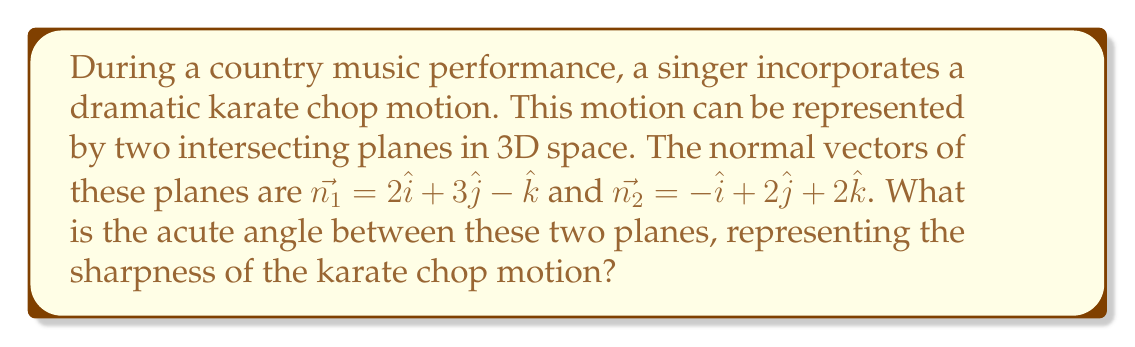Solve this math problem. To find the angle between two intersecting planes, we can use the dot product of their normal vectors. The formula for the angle $\theta$ between two planes with normal vectors $\vec{n_1}$ and $\vec{n_2}$ is:

$$\cos\theta = \frac{|\vec{n_1} \cdot \vec{n_2}|}{|\vec{n_1}||\vec{n_2}|}$$

Step 1: Calculate the dot product $\vec{n_1} \cdot \vec{n_2}$
$$\vec{n_1} \cdot \vec{n_2} = (2)(-1) + (3)(2) + (-1)(2) = -2 + 6 - 2 = 2$$

Step 2: Calculate the magnitudes of $\vec{n_1}$ and $\vec{n_2}$
$$|\vec{n_1}| = \sqrt{2^2 + 3^2 + (-1)^2} = \sqrt{4 + 9 + 1} = \sqrt{14}$$
$$|\vec{n_2}| = \sqrt{(-1)^2 + 2^2 + 2^2} = \sqrt{1 + 4 + 4} = 3$$

Step 3: Apply the formula
$$\cos\theta = \frac{|2|}{\sqrt{14} \cdot 3} = \frac{2}{3\sqrt{14}}$$

Step 4: Take the inverse cosine (arccos) of both sides
$$\theta = \arccos\left(\frac{2}{3\sqrt{14}}\right)$$

Step 5: Calculate the result (in radians)
$$\theta \approx 1.3181$$

Step 6: Convert to degrees
$$\theta \approx 75.52°$$
Answer: $75.52°$ 